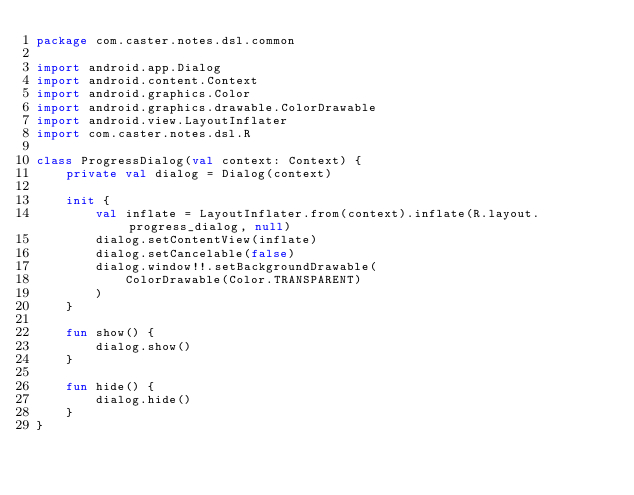Convert code to text. <code><loc_0><loc_0><loc_500><loc_500><_Kotlin_>package com.caster.notes.dsl.common

import android.app.Dialog
import android.content.Context
import android.graphics.Color
import android.graphics.drawable.ColorDrawable
import android.view.LayoutInflater
import com.caster.notes.dsl.R

class ProgressDialog(val context: Context) {
    private val dialog = Dialog(context)

    init {
        val inflate = LayoutInflater.from(context).inflate(R.layout.progress_dialog, null)
        dialog.setContentView(inflate)
        dialog.setCancelable(false)
        dialog.window!!.setBackgroundDrawable(
            ColorDrawable(Color.TRANSPARENT)
        )
    }

    fun show() {
        dialog.show()
    }

    fun hide() {
        dialog.hide()
    }
}</code> 